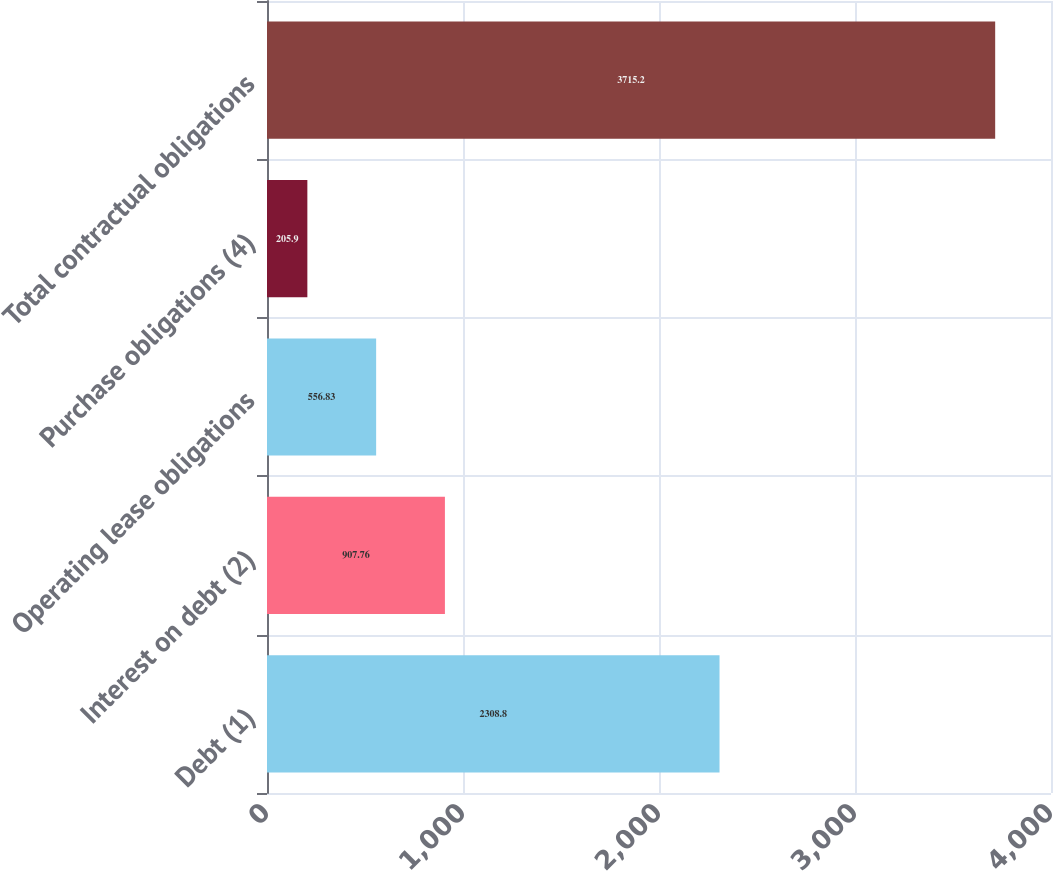Convert chart to OTSL. <chart><loc_0><loc_0><loc_500><loc_500><bar_chart><fcel>Debt (1)<fcel>Interest on debt (2)<fcel>Operating lease obligations<fcel>Purchase obligations (4)<fcel>Total contractual obligations<nl><fcel>2308.8<fcel>907.76<fcel>556.83<fcel>205.9<fcel>3715.2<nl></chart> 